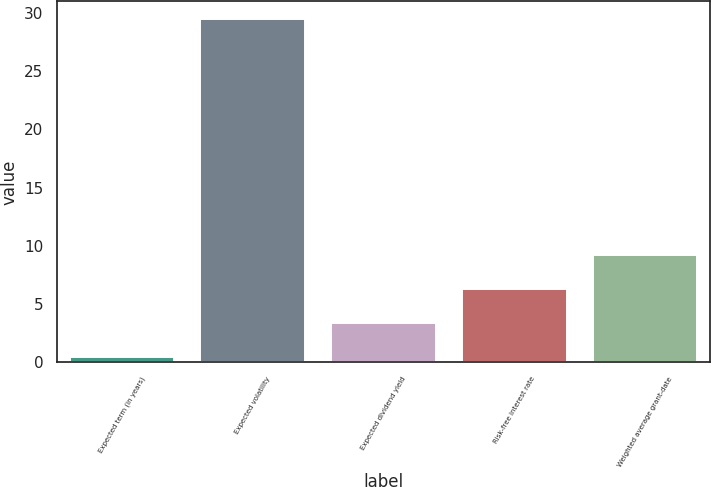<chart> <loc_0><loc_0><loc_500><loc_500><bar_chart><fcel>Expected term (in years)<fcel>Expected volatility<fcel>Expected dividend yield<fcel>Risk-free interest rate<fcel>Weighted average grant-date<nl><fcel>0.5<fcel>29.49<fcel>3.4<fcel>6.3<fcel>9.2<nl></chart> 